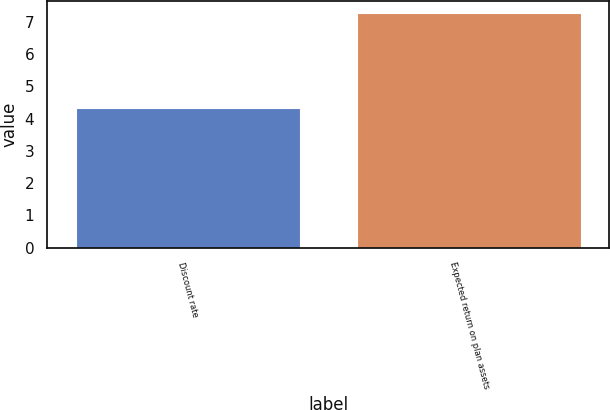<chart> <loc_0><loc_0><loc_500><loc_500><bar_chart><fcel>Discount rate<fcel>Expected return on plan assets<nl><fcel>4.32<fcel>7.28<nl></chart> 